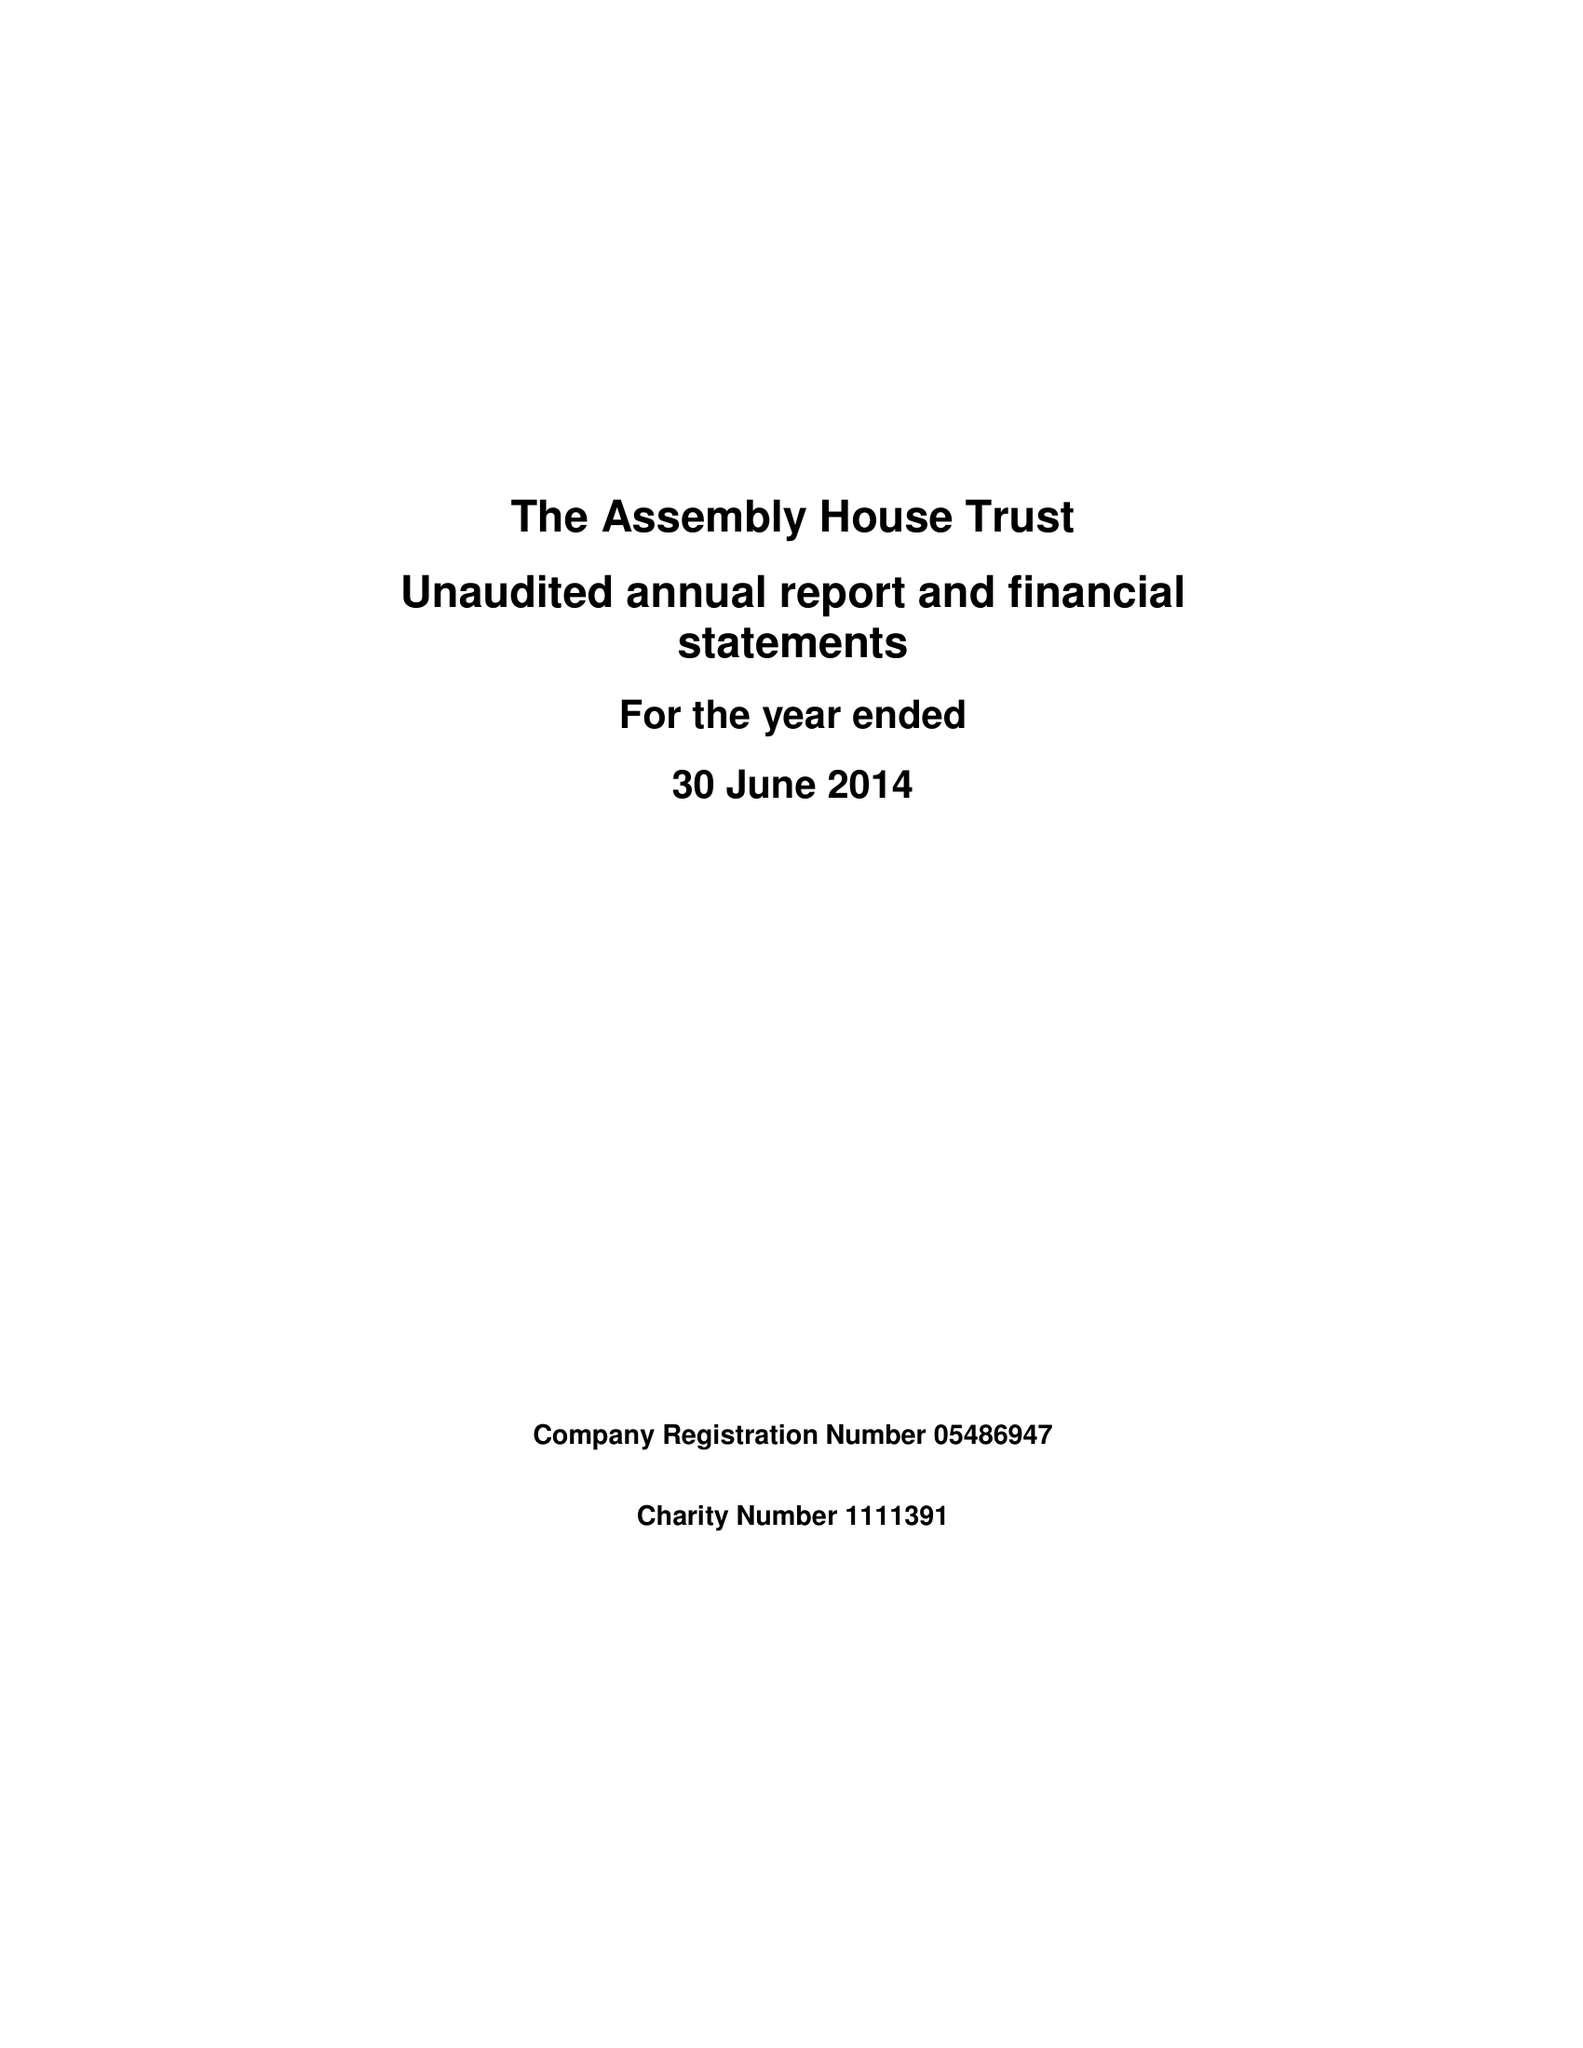What is the value for the spending_annually_in_british_pounds?
Answer the question using a single word or phrase. 69093.00 